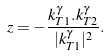Convert formula to latex. <formula><loc_0><loc_0><loc_500><loc_500>z = - \frac { k _ { T 1 } ^ { \gamma } . k _ { T 2 } ^ { \gamma } } { | k _ { T 1 } ^ { \gamma } | ^ { 2 } } .</formula> 